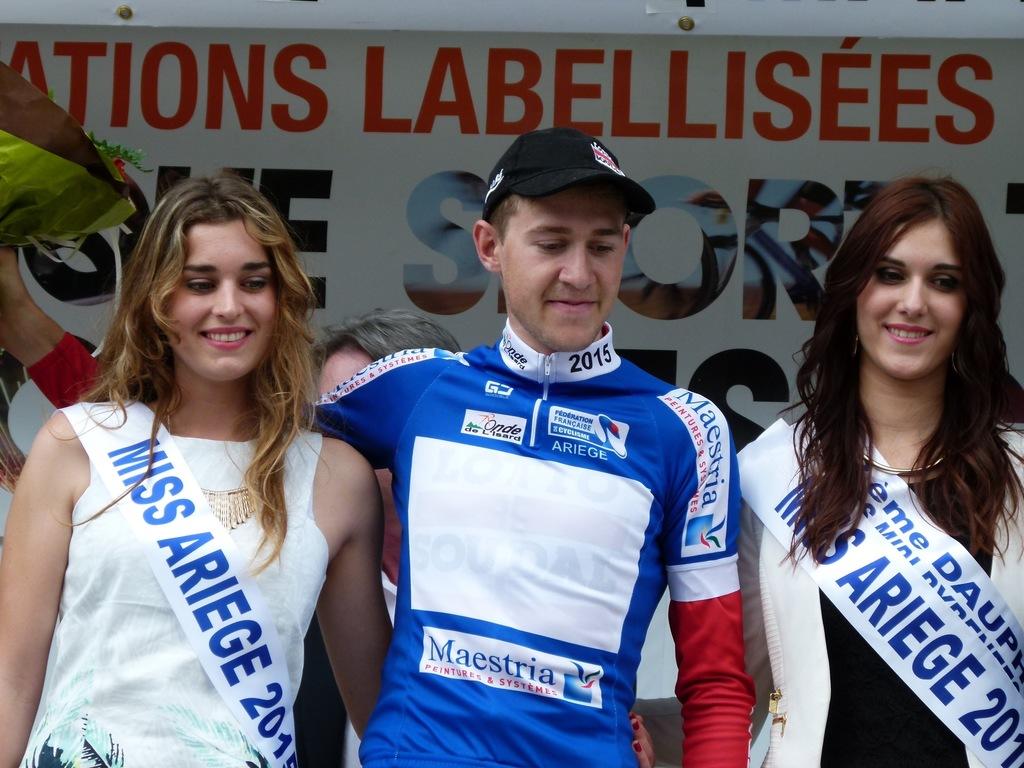What year is on his uniform collar?
Keep it short and to the point. 2015. Where are these ladies from?
Give a very brief answer. Ariege. 